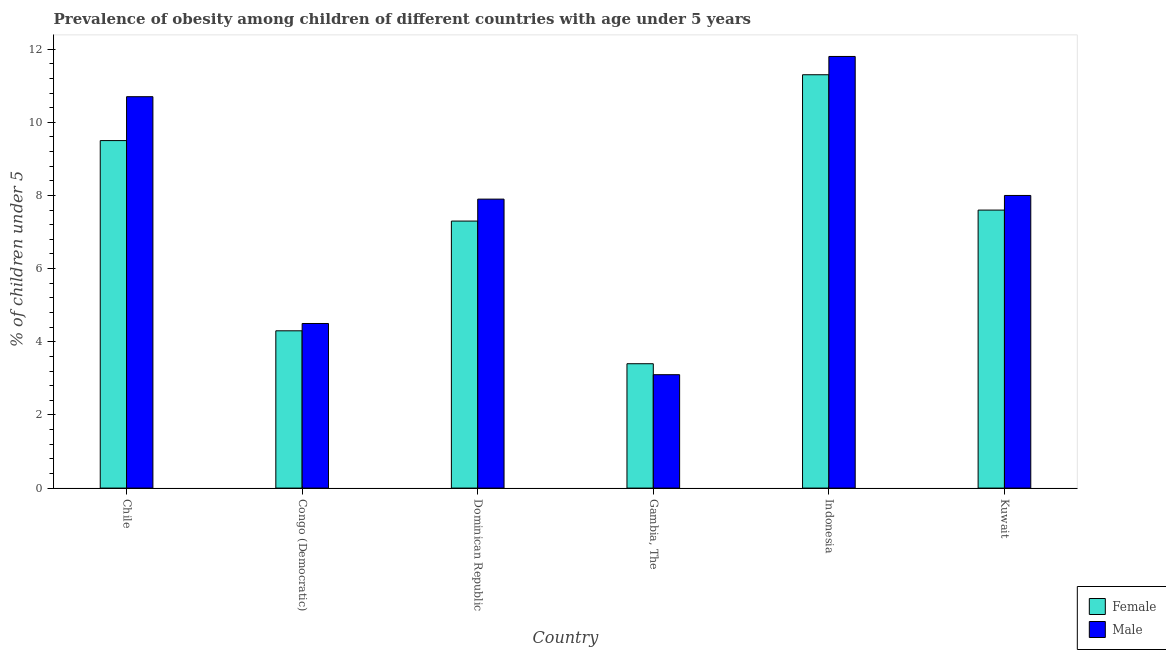How many different coloured bars are there?
Offer a very short reply. 2. Are the number of bars per tick equal to the number of legend labels?
Make the answer very short. Yes. Are the number of bars on each tick of the X-axis equal?
Make the answer very short. Yes. How many bars are there on the 4th tick from the left?
Your response must be concise. 2. In how many cases, is the number of bars for a given country not equal to the number of legend labels?
Give a very brief answer. 0. What is the percentage of obese male children in Chile?
Offer a terse response. 10.7. Across all countries, what is the maximum percentage of obese female children?
Your answer should be very brief. 11.3. Across all countries, what is the minimum percentage of obese male children?
Offer a terse response. 3.1. In which country was the percentage of obese female children maximum?
Your response must be concise. Indonesia. In which country was the percentage of obese male children minimum?
Offer a very short reply. Gambia, The. What is the difference between the percentage of obese female children in Gambia, The and that in Indonesia?
Provide a succinct answer. -7.9. What is the average percentage of obese male children per country?
Offer a very short reply. 7.67. What is the difference between the percentage of obese female children and percentage of obese male children in Gambia, The?
Offer a terse response. 0.3. What is the ratio of the percentage of obese female children in Congo (Democratic) to that in Dominican Republic?
Ensure brevity in your answer.  0.59. Is the percentage of obese male children in Chile less than that in Gambia, The?
Your response must be concise. No. Is the difference between the percentage of obese male children in Congo (Democratic) and Dominican Republic greater than the difference between the percentage of obese female children in Congo (Democratic) and Dominican Republic?
Offer a very short reply. No. What is the difference between the highest and the second highest percentage of obese male children?
Keep it short and to the point. 1.1. What is the difference between the highest and the lowest percentage of obese female children?
Provide a short and direct response. 7.9. In how many countries, is the percentage of obese female children greater than the average percentage of obese female children taken over all countries?
Ensure brevity in your answer.  4. Is the sum of the percentage of obese male children in Dominican Republic and Gambia, The greater than the maximum percentage of obese female children across all countries?
Make the answer very short. No. What does the 1st bar from the left in Kuwait represents?
Your answer should be very brief. Female. What does the 1st bar from the right in Kuwait represents?
Keep it short and to the point. Male. How many bars are there?
Give a very brief answer. 12. Are all the bars in the graph horizontal?
Give a very brief answer. No. What is the difference between two consecutive major ticks on the Y-axis?
Give a very brief answer. 2. How many legend labels are there?
Offer a very short reply. 2. How are the legend labels stacked?
Offer a very short reply. Vertical. What is the title of the graph?
Give a very brief answer. Prevalence of obesity among children of different countries with age under 5 years. Does "IMF concessional" appear as one of the legend labels in the graph?
Your answer should be very brief. No. What is the label or title of the X-axis?
Keep it short and to the point. Country. What is the label or title of the Y-axis?
Provide a short and direct response.  % of children under 5. What is the  % of children under 5 in Female in Chile?
Offer a very short reply. 9.5. What is the  % of children under 5 in Male in Chile?
Ensure brevity in your answer.  10.7. What is the  % of children under 5 in Female in Congo (Democratic)?
Keep it short and to the point. 4.3. What is the  % of children under 5 of Male in Congo (Democratic)?
Your answer should be very brief. 4.5. What is the  % of children under 5 in Female in Dominican Republic?
Provide a succinct answer. 7.3. What is the  % of children under 5 of Male in Dominican Republic?
Keep it short and to the point. 7.9. What is the  % of children under 5 of Female in Gambia, The?
Offer a terse response. 3.4. What is the  % of children under 5 of Male in Gambia, The?
Offer a very short reply. 3.1. What is the  % of children under 5 of Female in Indonesia?
Ensure brevity in your answer.  11.3. What is the  % of children under 5 in Male in Indonesia?
Your answer should be compact. 11.8. What is the  % of children under 5 of Female in Kuwait?
Provide a short and direct response. 7.6. What is the  % of children under 5 of Male in Kuwait?
Provide a short and direct response. 8. Across all countries, what is the maximum  % of children under 5 in Female?
Your answer should be very brief. 11.3. Across all countries, what is the maximum  % of children under 5 of Male?
Provide a short and direct response. 11.8. Across all countries, what is the minimum  % of children under 5 of Female?
Offer a terse response. 3.4. Across all countries, what is the minimum  % of children under 5 in Male?
Offer a very short reply. 3.1. What is the total  % of children under 5 in Female in the graph?
Give a very brief answer. 43.4. What is the difference between the  % of children under 5 of Female in Chile and that in Congo (Democratic)?
Offer a terse response. 5.2. What is the difference between the  % of children under 5 of Male in Chile and that in Congo (Democratic)?
Provide a short and direct response. 6.2. What is the difference between the  % of children under 5 of Female in Chile and that in Dominican Republic?
Provide a short and direct response. 2.2. What is the difference between the  % of children under 5 in Male in Chile and that in Dominican Republic?
Provide a short and direct response. 2.8. What is the difference between the  % of children under 5 of Female in Chile and that in Indonesia?
Your response must be concise. -1.8. What is the difference between the  % of children under 5 of Female in Congo (Democratic) and that in Dominican Republic?
Give a very brief answer. -3. What is the difference between the  % of children under 5 of Male in Congo (Democratic) and that in Kuwait?
Ensure brevity in your answer.  -3.5. What is the difference between the  % of children under 5 of Female in Dominican Republic and that in Indonesia?
Ensure brevity in your answer.  -4. What is the difference between the  % of children under 5 in Male in Dominican Republic and that in Indonesia?
Ensure brevity in your answer.  -3.9. What is the difference between the  % of children under 5 in Male in Dominican Republic and that in Kuwait?
Your answer should be compact. -0.1. What is the difference between the  % of children under 5 of Male in Gambia, The and that in Indonesia?
Make the answer very short. -8.7. What is the difference between the  % of children under 5 of Female in Gambia, The and that in Kuwait?
Your answer should be compact. -4.2. What is the difference between the  % of children under 5 of Male in Indonesia and that in Kuwait?
Keep it short and to the point. 3.8. What is the difference between the  % of children under 5 in Female in Chile and the  % of children under 5 in Male in Congo (Democratic)?
Offer a terse response. 5. What is the difference between the  % of children under 5 of Female in Chile and the  % of children under 5 of Male in Dominican Republic?
Your answer should be very brief. 1.6. What is the difference between the  % of children under 5 of Female in Chile and the  % of children under 5 of Male in Gambia, The?
Give a very brief answer. 6.4. What is the difference between the  % of children under 5 in Female in Chile and the  % of children under 5 in Male in Indonesia?
Provide a succinct answer. -2.3. What is the difference between the  % of children under 5 of Female in Congo (Democratic) and the  % of children under 5 of Male in Indonesia?
Your answer should be very brief. -7.5. What is the difference between the  % of children under 5 of Female in Gambia, The and the  % of children under 5 of Male in Indonesia?
Your answer should be compact. -8.4. What is the difference between the  % of children under 5 of Female in Indonesia and the  % of children under 5 of Male in Kuwait?
Give a very brief answer. 3.3. What is the average  % of children under 5 of Female per country?
Provide a short and direct response. 7.23. What is the average  % of children under 5 of Male per country?
Give a very brief answer. 7.67. What is the difference between the  % of children under 5 in Female and  % of children under 5 in Male in Chile?
Your answer should be compact. -1.2. What is the difference between the  % of children under 5 in Female and  % of children under 5 in Male in Congo (Democratic)?
Provide a short and direct response. -0.2. What is the difference between the  % of children under 5 in Female and  % of children under 5 in Male in Indonesia?
Give a very brief answer. -0.5. What is the difference between the  % of children under 5 in Female and  % of children under 5 in Male in Kuwait?
Provide a short and direct response. -0.4. What is the ratio of the  % of children under 5 of Female in Chile to that in Congo (Democratic)?
Make the answer very short. 2.21. What is the ratio of the  % of children under 5 of Male in Chile to that in Congo (Democratic)?
Provide a short and direct response. 2.38. What is the ratio of the  % of children under 5 in Female in Chile to that in Dominican Republic?
Your answer should be compact. 1.3. What is the ratio of the  % of children under 5 in Male in Chile to that in Dominican Republic?
Ensure brevity in your answer.  1.35. What is the ratio of the  % of children under 5 in Female in Chile to that in Gambia, The?
Offer a terse response. 2.79. What is the ratio of the  % of children under 5 of Male in Chile to that in Gambia, The?
Your answer should be very brief. 3.45. What is the ratio of the  % of children under 5 in Female in Chile to that in Indonesia?
Your answer should be compact. 0.84. What is the ratio of the  % of children under 5 of Male in Chile to that in Indonesia?
Offer a very short reply. 0.91. What is the ratio of the  % of children under 5 in Female in Chile to that in Kuwait?
Your response must be concise. 1.25. What is the ratio of the  % of children under 5 of Male in Chile to that in Kuwait?
Your answer should be compact. 1.34. What is the ratio of the  % of children under 5 in Female in Congo (Democratic) to that in Dominican Republic?
Offer a very short reply. 0.59. What is the ratio of the  % of children under 5 of Male in Congo (Democratic) to that in Dominican Republic?
Your response must be concise. 0.57. What is the ratio of the  % of children under 5 in Female in Congo (Democratic) to that in Gambia, The?
Your answer should be very brief. 1.26. What is the ratio of the  % of children under 5 of Male in Congo (Democratic) to that in Gambia, The?
Provide a short and direct response. 1.45. What is the ratio of the  % of children under 5 of Female in Congo (Democratic) to that in Indonesia?
Make the answer very short. 0.38. What is the ratio of the  % of children under 5 in Male in Congo (Democratic) to that in Indonesia?
Provide a short and direct response. 0.38. What is the ratio of the  % of children under 5 in Female in Congo (Democratic) to that in Kuwait?
Your response must be concise. 0.57. What is the ratio of the  % of children under 5 in Male in Congo (Democratic) to that in Kuwait?
Offer a very short reply. 0.56. What is the ratio of the  % of children under 5 in Female in Dominican Republic to that in Gambia, The?
Ensure brevity in your answer.  2.15. What is the ratio of the  % of children under 5 in Male in Dominican Republic to that in Gambia, The?
Give a very brief answer. 2.55. What is the ratio of the  % of children under 5 in Female in Dominican Republic to that in Indonesia?
Make the answer very short. 0.65. What is the ratio of the  % of children under 5 of Male in Dominican Republic to that in Indonesia?
Give a very brief answer. 0.67. What is the ratio of the  % of children under 5 of Female in Dominican Republic to that in Kuwait?
Offer a terse response. 0.96. What is the ratio of the  % of children under 5 in Male in Dominican Republic to that in Kuwait?
Offer a very short reply. 0.99. What is the ratio of the  % of children under 5 of Female in Gambia, The to that in Indonesia?
Provide a succinct answer. 0.3. What is the ratio of the  % of children under 5 of Male in Gambia, The to that in Indonesia?
Offer a terse response. 0.26. What is the ratio of the  % of children under 5 of Female in Gambia, The to that in Kuwait?
Your response must be concise. 0.45. What is the ratio of the  % of children under 5 in Male in Gambia, The to that in Kuwait?
Offer a very short reply. 0.39. What is the ratio of the  % of children under 5 of Female in Indonesia to that in Kuwait?
Your response must be concise. 1.49. What is the ratio of the  % of children under 5 in Male in Indonesia to that in Kuwait?
Make the answer very short. 1.48. What is the difference between the highest and the second highest  % of children under 5 of Female?
Offer a very short reply. 1.8. What is the difference between the highest and the second highest  % of children under 5 of Male?
Make the answer very short. 1.1. 